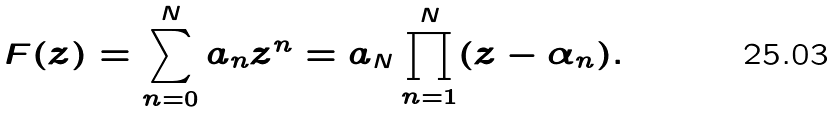<formula> <loc_0><loc_0><loc_500><loc_500>F ( z ) = \sum _ { n = 0 } ^ { N } a _ { n } z ^ { n } = a _ { N } \prod _ { n = 1 } ^ { N } ( z - \alpha _ { n } ) .</formula> 